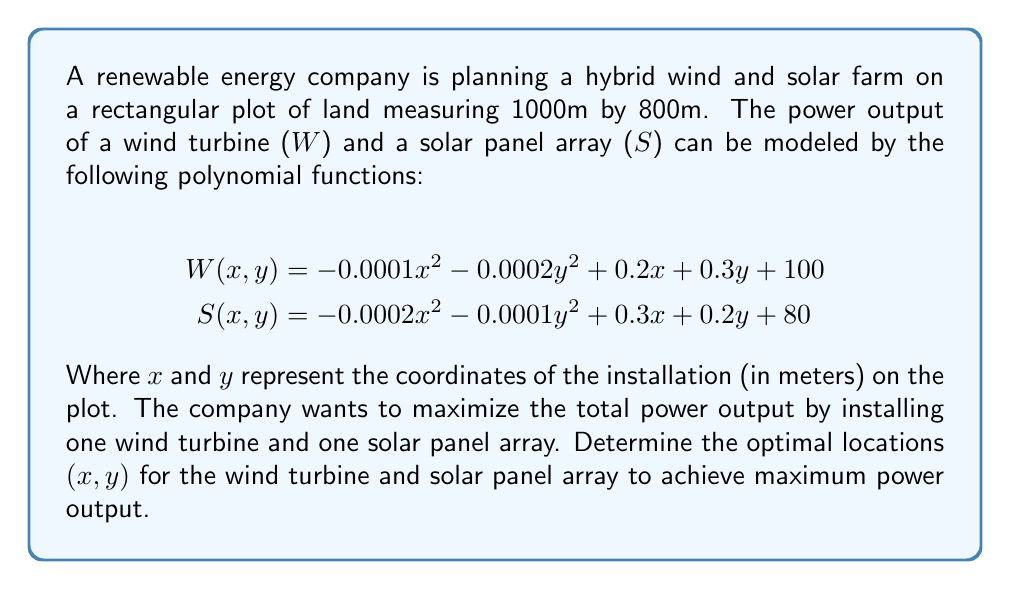What is the answer to this math problem? To solve this optimization problem, we need to follow these steps:

1) The total power output function P(x1, y1, x2, y2) is the sum of W(x1, y1) and S(x2, y2):

   $$P(x1,y1,x2,y2) = W(x1,y1) + S(x2,y2)$$

2) Substitute the given functions:

   $$P(x1,y1,x2,y2) = (-0.0001x1^2 - 0.0002y1^2 + 0.2x1 + 0.3y1 + 100) + (-0.0002x2^2 - 0.0001y2^2 + 0.3x2 + 0.2y2 + 80)$$

3) To find the maximum, we need to calculate partial derivatives with respect to x1, y1, x2, and y2 and set them to zero:

   $$\frac{\partial P}{\partial x1} = -0.0002x1 + 0.2 = 0$$
   $$\frac{\partial P}{\partial y1} = -0.0004y1 + 0.3 = 0$$
   $$\frac{\partial P}{\partial x2} = -0.0004x2 + 0.3 = 0$$
   $$\frac{\partial P}{\partial y2} = -0.0002y2 + 0.2 = 0$$

4) Solve these equations:

   $$x1 = 1000, y1 = 750$$
   $$x2 = 750, y2 = 1000$$

5) Check if these points are within the plot boundaries (1000m x 800m):
   x1 and x2 are within bounds, but y2 exceeds the 800m limit. We need to adjust y2 to the maximum possible value, 800m.

6) Calculate the adjusted x2 using the partial derivative equation:

   $$-0.0004x2 + 0.3 = 0$$
   $$x2 = 750$$

7) Therefore, the optimal locations are:
   Wind turbine: (1000, 750)
   Solar panel array: (750, 800)

8) Verify that these points give the maximum power output within the given boundaries.
Answer: Wind turbine: (1000m, 750m); Solar panel array: (750m, 800m) 